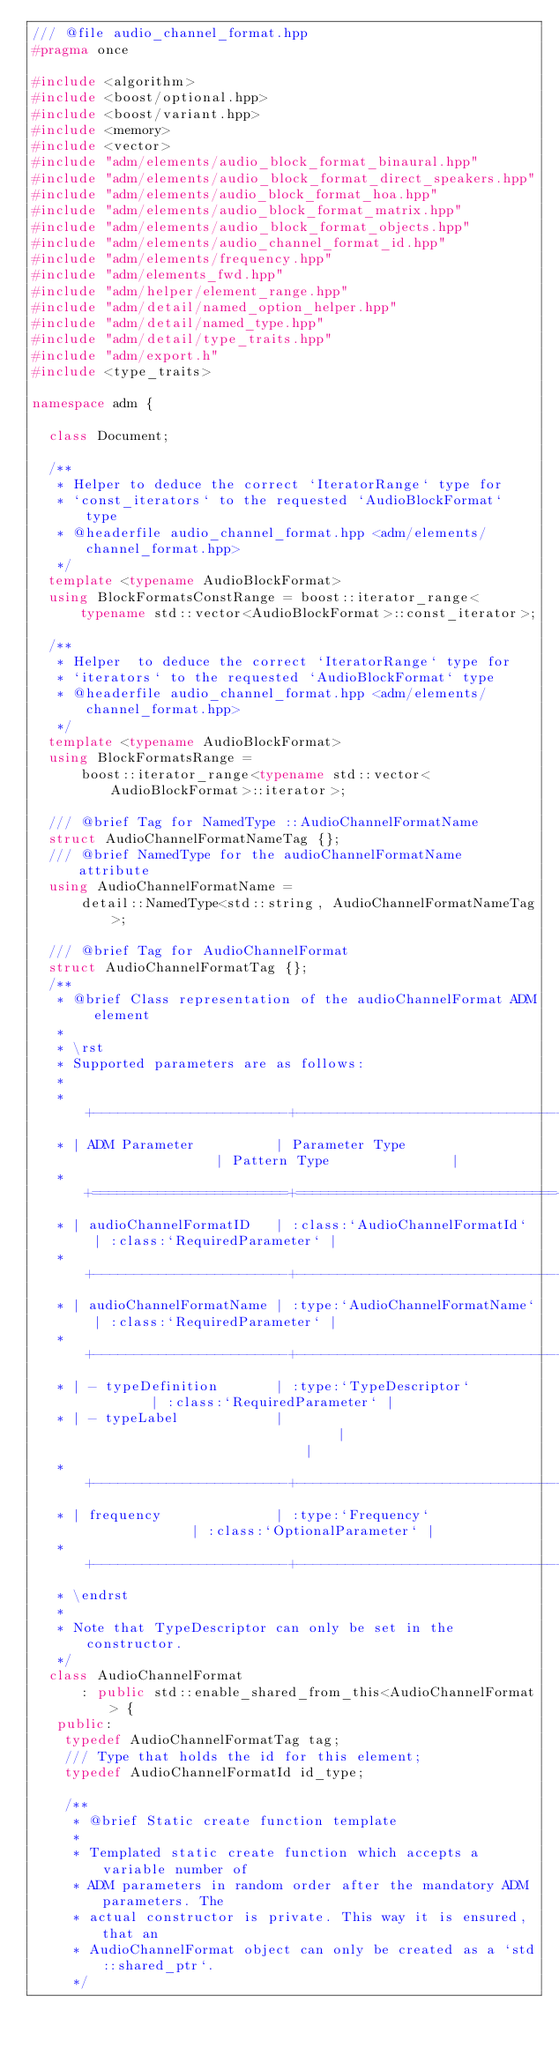Convert code to text. <code><loc_0><loc_0><loc_500><loc_500><_C++_>/// @file audio_channel_format.hpp
#pragma once

#include <algorithm>
#include <boost/optional.hpp>
#include <boost/variant.hpp>
#include <memory>
#include <vector>
#include "adm/elements/audio_block_format_binaural.hpp"
#include "adm/elements/audio_block_format_direct_speakers.hpp"
#include "adm/elements/audio_block_format_hoa.hpp"
#include "adm/elements/audio_block_format_matrix.hpp"
#include "adm/elements/audio_block_format_objects.hpp"
#include "adm/elements/audio_channel_format_id.hpp"
#include "adm/elements/frequency.hpp"
#include "adm/elements_fwd.hpp"
#include "adm/helper/element_range.hpp"
#include "adm/detail/named_option_helper.hpp"
#include "adm/detail/named_type.hpp"
#include "adm/detail/type_traits.hpp"
#include "adm/export.h"
#include <type_traits>

namespace adm {

  class Document;

  /**
   * Helper to deduce the correct `IteratorRange` type for
   * `const_iterators` to the requested `AudioBlockFormat` type
   * @headerfile audio_channel_format.hpp <adm/elements/channel_format.hpp>
   */
  template <typename AudioBlockFormat>
  using BlockFormatsConstRange = boost::iterator_range<
      typename std::vector<AudioBlockFormat>::const_iterator>;

  /**
   * Helper  to deduce the correct `IteratorRange` type for
   * `iterators` to the requested `AudioBlockFormat` type
   * @headerfile audio_channel_format.hpp <adm/elements/channel_format.hpp>
   */
  template <typename AudioBlockFormat>
  using BlockFormatsRange =
      boost::iterator_range<typename std::vector<AudioBlockFormat>::iterator>;

  /// @brief Tag for NamedType ::AudioChannelFormatName
  struct AudioChannelFormatNameTag {};
  /// @brief NamedType for the audioChannelFormatName attribute
  using AudioChannelFormatName =
      detail::NamedType<std::string, AudioChannelFormatNameTag>;

  /// @brief Tag for AudioChannelFormat
  struct AudioChannelFormatTag {};
  /**
   * @brief Class representation of the audioChannelFormat ADM element
   *
   * \rst
   * Supported parameters are as follows:
   *
   * +------------------------+--------------------------------+----------------------------+
   * | ADM Parameter          | Parameter Type                 | Pattern Type               |
   * +========================+================================+============================+
   * | audioChannelFormatID   | :class:`AudioChannelFormatId`  | :class:`RequiredParameter` |
   * +------------------------+--------------------------------+----------------------------+
   * | audioChannelFormatName | :type:`AudioChannelFormatName` | :class:`RequiredParameter` |
   * +------------------------+--------------------------------+----------------------------+
   * | - typeDefinition       | :type:`TypeDescriptor`         | :class:`RequiredParameter` |
   * | - typeLabel            |                                |                            |
   * +------------------------+--------------------------------+----------------------------+
   * | frequency              | :type:`Frequency`              | :class:`OptionalParameter` |
   * +------------------------+--------------------------------+----------------------------+
   * \endrst
   *
   * Note that TypeDescriptor can only be set in the constructor.
   */
  class AudioChannelFormat
      : public std::enable_shared_from_this<AudioChannelFormat> {
   public:
    typedef AudioChannelFormatTag tag;
    /// Type that holds the id for this element;
    typedef AudioChannelFormatId id_type;

    /**
     * @brief Static create function template
     *
     * Templated static create function which accepts a variable number of
     * ADM parameters in random order after the mandatory ADM parameters. The
     * actual constructor is private. This way it is ensured, that an
     * AudioChannelFormat object can only be created as a `std::shared_ptr`.
     */</code> 